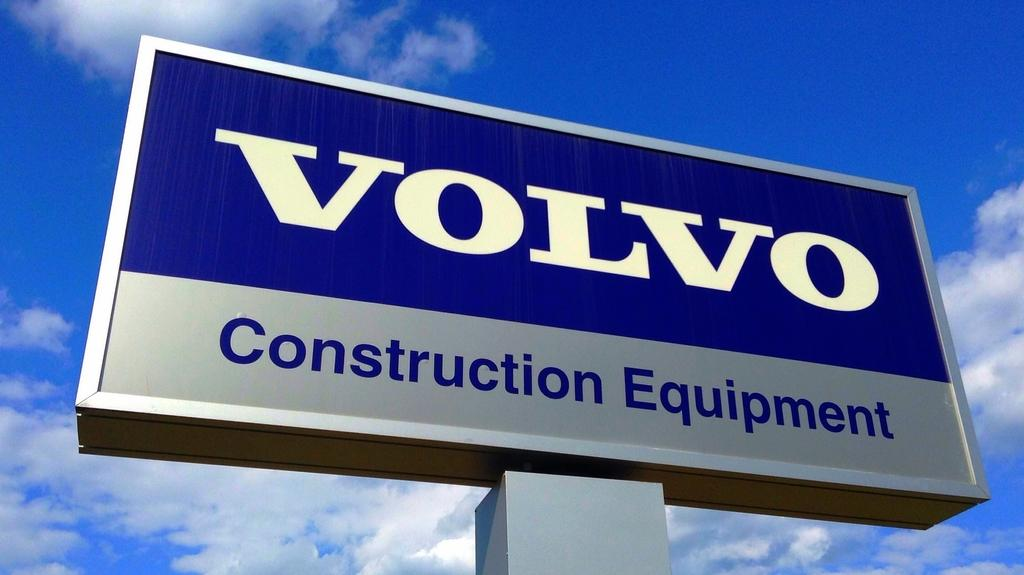<image>
Give a short and clear explanation of the subsequent image. A large sign has a blue sky behind it and the brand name Volvo on it. 